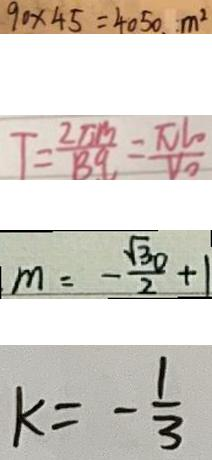<formula> <loc_0><loc_0><loc_500><loc_500>9 0 \times 4 5 = 4 0 5 0 . m ^ { 2 } 
 T = \frac { 2 \pi m } { B q } = \frac { \pi l _ { 0 } } { V _ { 0 } } 
 m = - \frac { \sqrt { 3 0 } } { 2 } + 1 
 k = - \frac { 1 } { 3 }</formula> 